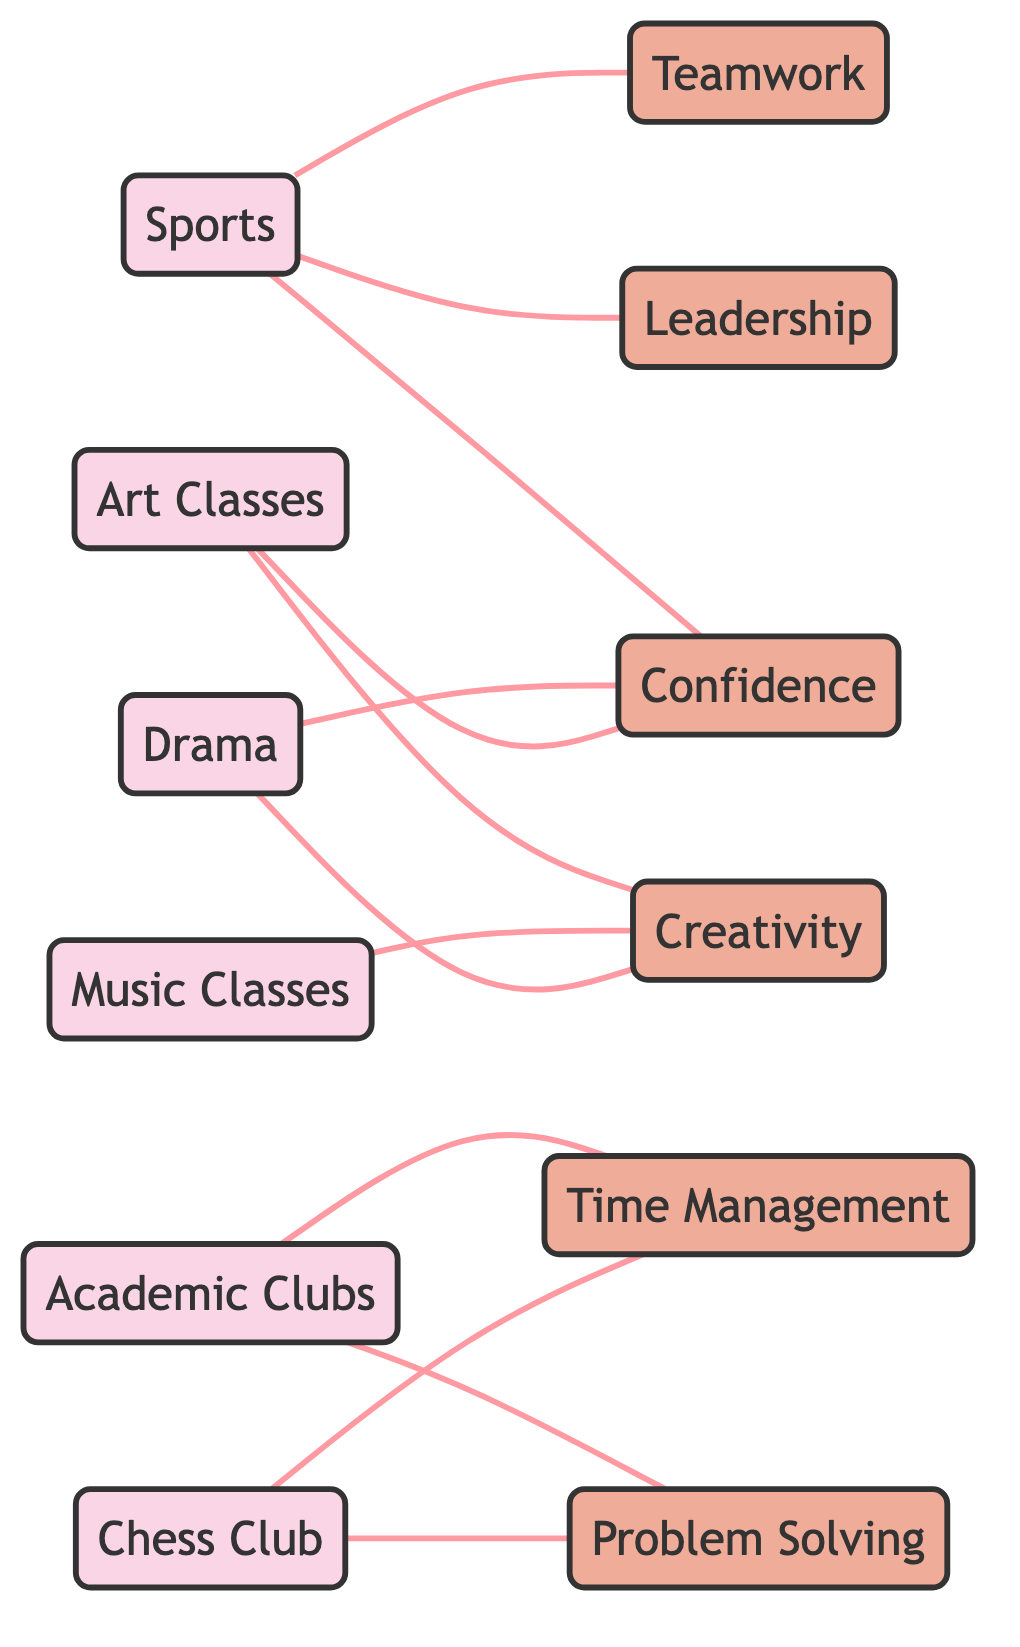What activities are linked to Creativity? The diagram displays connections from two activities, Art Classes and Music Classes, that both link to Creativity. By identifying the edges connected to Creativity, we can see which activities contribute to developing this skill.
Answer: Art Classes, Music Classes How many skills are represented in the diagram? The diagram lists six skills in total: Teamwork, Leadership, Confidence, Creativity, Time Management, and Problem Solving. By counting the labeled nodes marked as skills, we arrive at the total number.
Answer: 6 Which skill is linked to both Sports and Drama? Analyzing the edges connected to the Sports and Drama nodes reveals that both connect to the skill Confidence. This requires examining the paths to see what skills associate with each activity.
Answer: Confidence What activity is associated with Time Management? By scanning the diagram, the Academic Clubs and Chess Club nodes link to the skill Time Management. Therefore, when asked which activity relates directly to this skill, those two would be the answer.
Answer: Academic Clubs, Chess Club Which activity contributes to the development of Problem Solving? Looking at the edges, we see that both Academic Clubs and Chess Club connect to the Problem Solving skill. Thus, we can conclude which activities support this particular skill development.
Answer: Academic Clubs, Chess Club How many edges connect Sports to skills? The diagram shows that Sports connects to three skills: Teamwork, Leadership, and Confidence. By counting the edges extending from the Sports node to these skills, we determine the total number of connections.
Answer: 3 